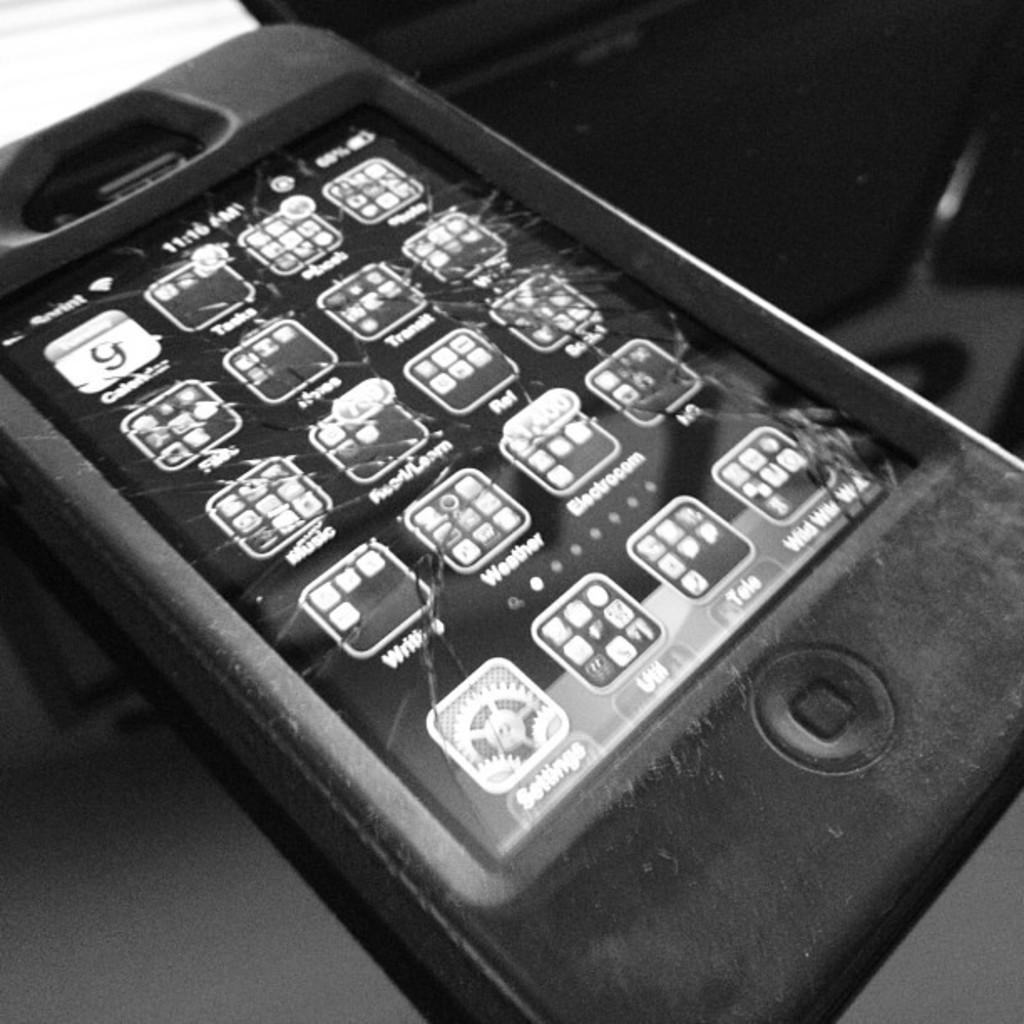Provide a one-sentence caption for the provided image. An iPhone in a thick case has a cracked screen and the first app says Calendar. 